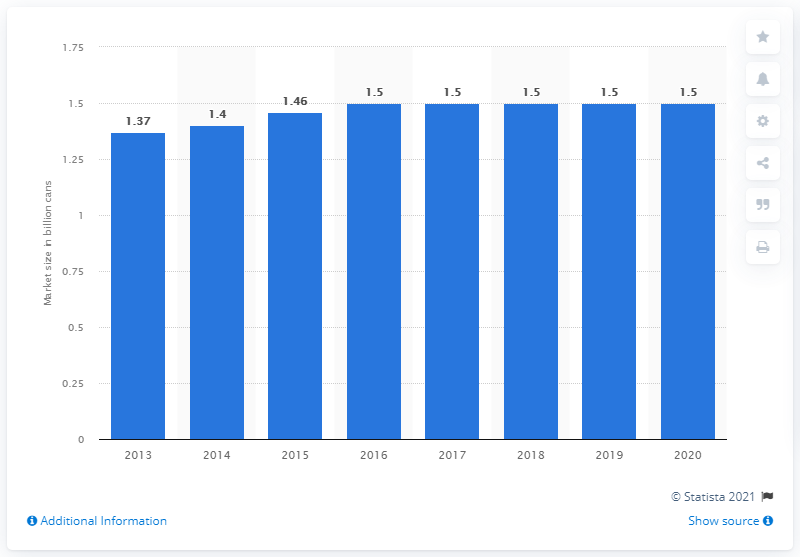Point out several critical features in this image. In the United States, the sale of cans of moist snuff increased from 2013 to 2020, with a total of 1.5 billion cans sold during this time period. 